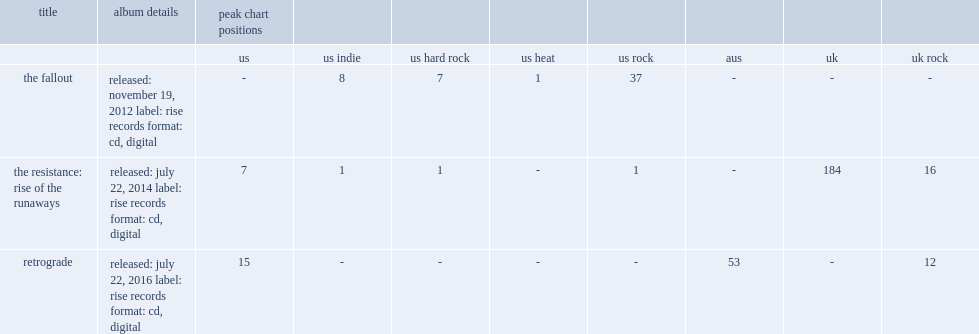What was the peak chart position on the hard rock of the resistance: rise of the runaways? 1.0. 